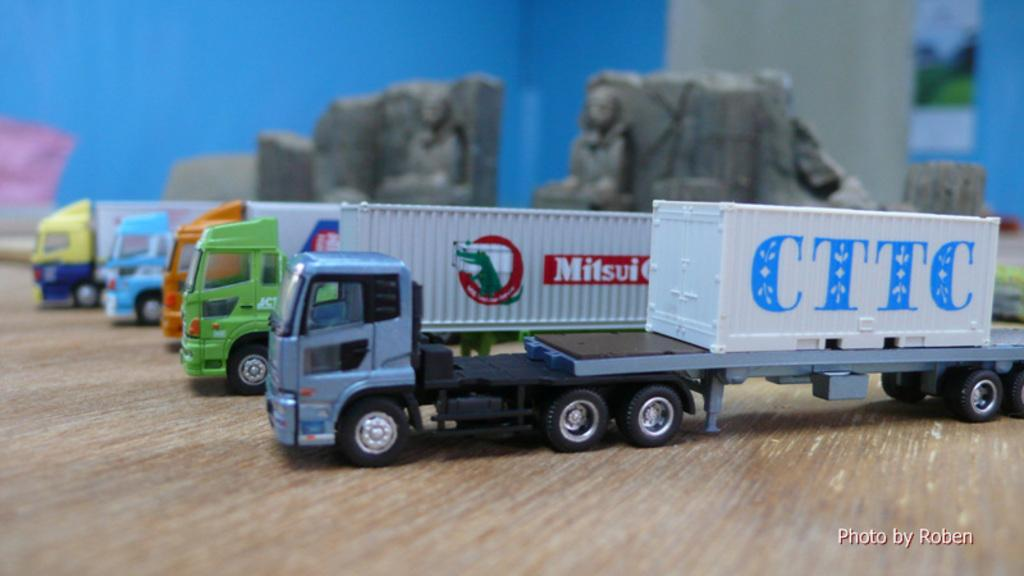What is present on the ground in the image? There are vehicles on the ground in the image. What color is the background of the image? The background of the image is blue. Is there any text visible in the image? Yes, there is some text in the bottom right corner of the image. What type of copper material can be seen in the image? There is no copper material present in the image. Are there any slaves depicted in the image? There is no depiction of slavery or slaves in the image. 